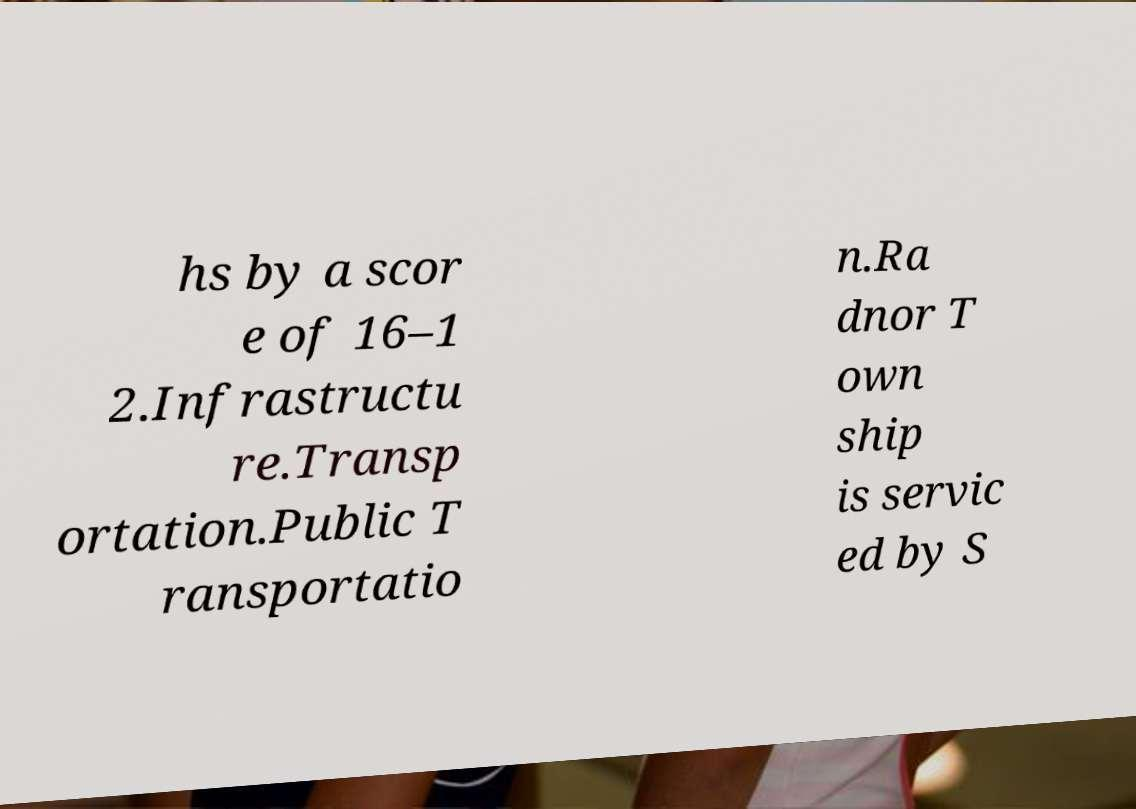I need the written content from this picture converted into text. Can you do that? hs by a scor e of 16–1 2.Infrastructu re.Transp ortation.Public T ransportatio n.Ra dnor T own ship is servic ed by S 